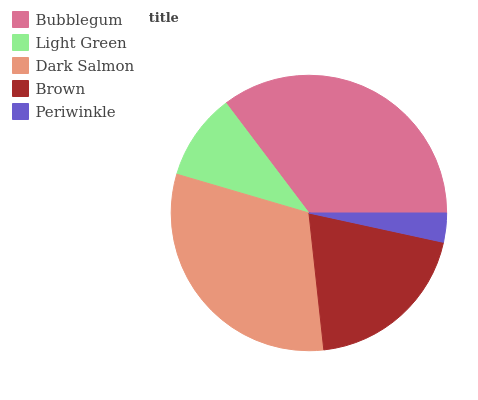Is Periwinkle the minimum?
Answer yes or no. Yes. Is Bubblegum the maximum?
Answer yes or no. Yes. Is Light Green the minimum?
Answer yes or no. No. Is Light Green the maximum?
Answer yes or no. No. Is Bubblegum greater than Light Green?
Answer yes or no. Yes. Is Light Green less than Bubblegum?
Answer yes or no. Yes. Is Light Green greater than Bubblegum?
Answer yes or no. No. Is Bubblegum less than Light Green?
Answer yes or no. No. Is Brown the high median?
Answer yes or no. Yes. Is Brown the low median?
Answer yes or no. Yes. Is Periwinkle the high median?
Answer yes or no. No. Is Periwinkle the low median?
Answer yes or no. No. 